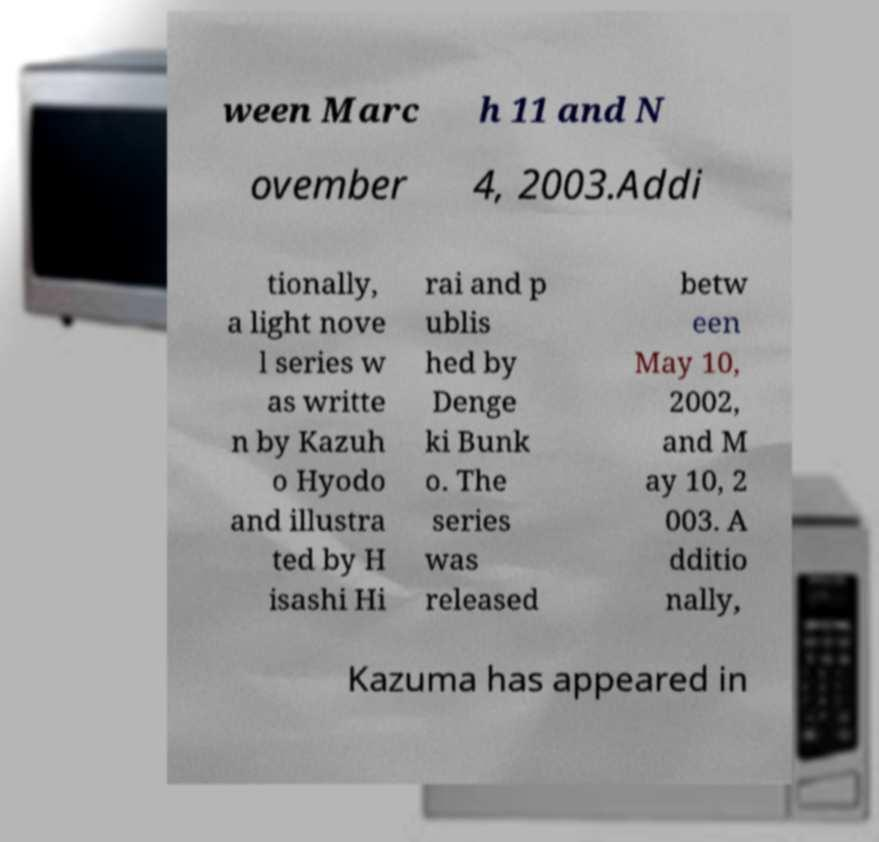Can you read and provide the text displayed in the image?This photo seems to have some interesting text. Can you extract and type it out for me? ween Marc h 11 and N ovember 4, 2003.Addi tionally, a light nove l series w as writte n by Kazuh o Hyodo and illustra ted by H isashi Hi rai and p ublis hed by Denge ki Bunk o. The series was released betw een May 10, 2002, and M ay 10, 2 003. A dditio nally, Kazuma has appeared in 